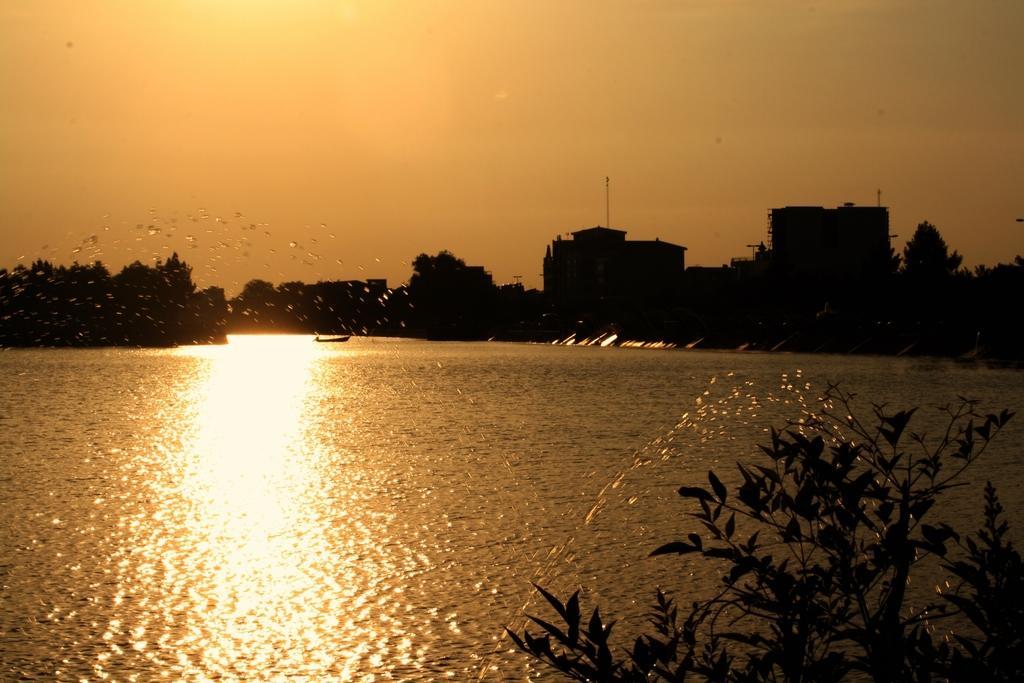In one or two sentences, can you explain what this image depicts? In the picture we can see a part of the plant and behind it, we can see the water surface and far away from it, we can see the trees and two buildings and in the background we can see the sky. 